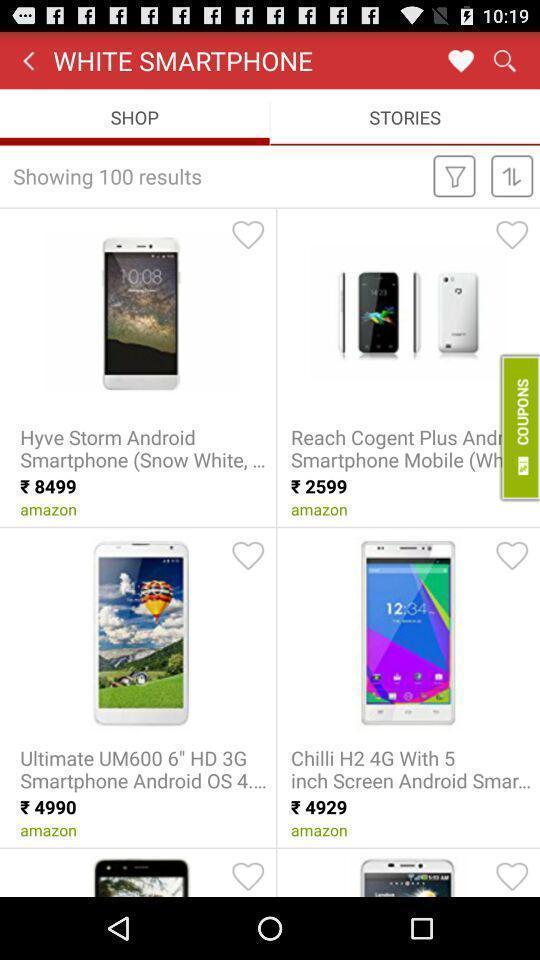Give me a narrative description of this picture. Page displaying search results of an shopping app. 